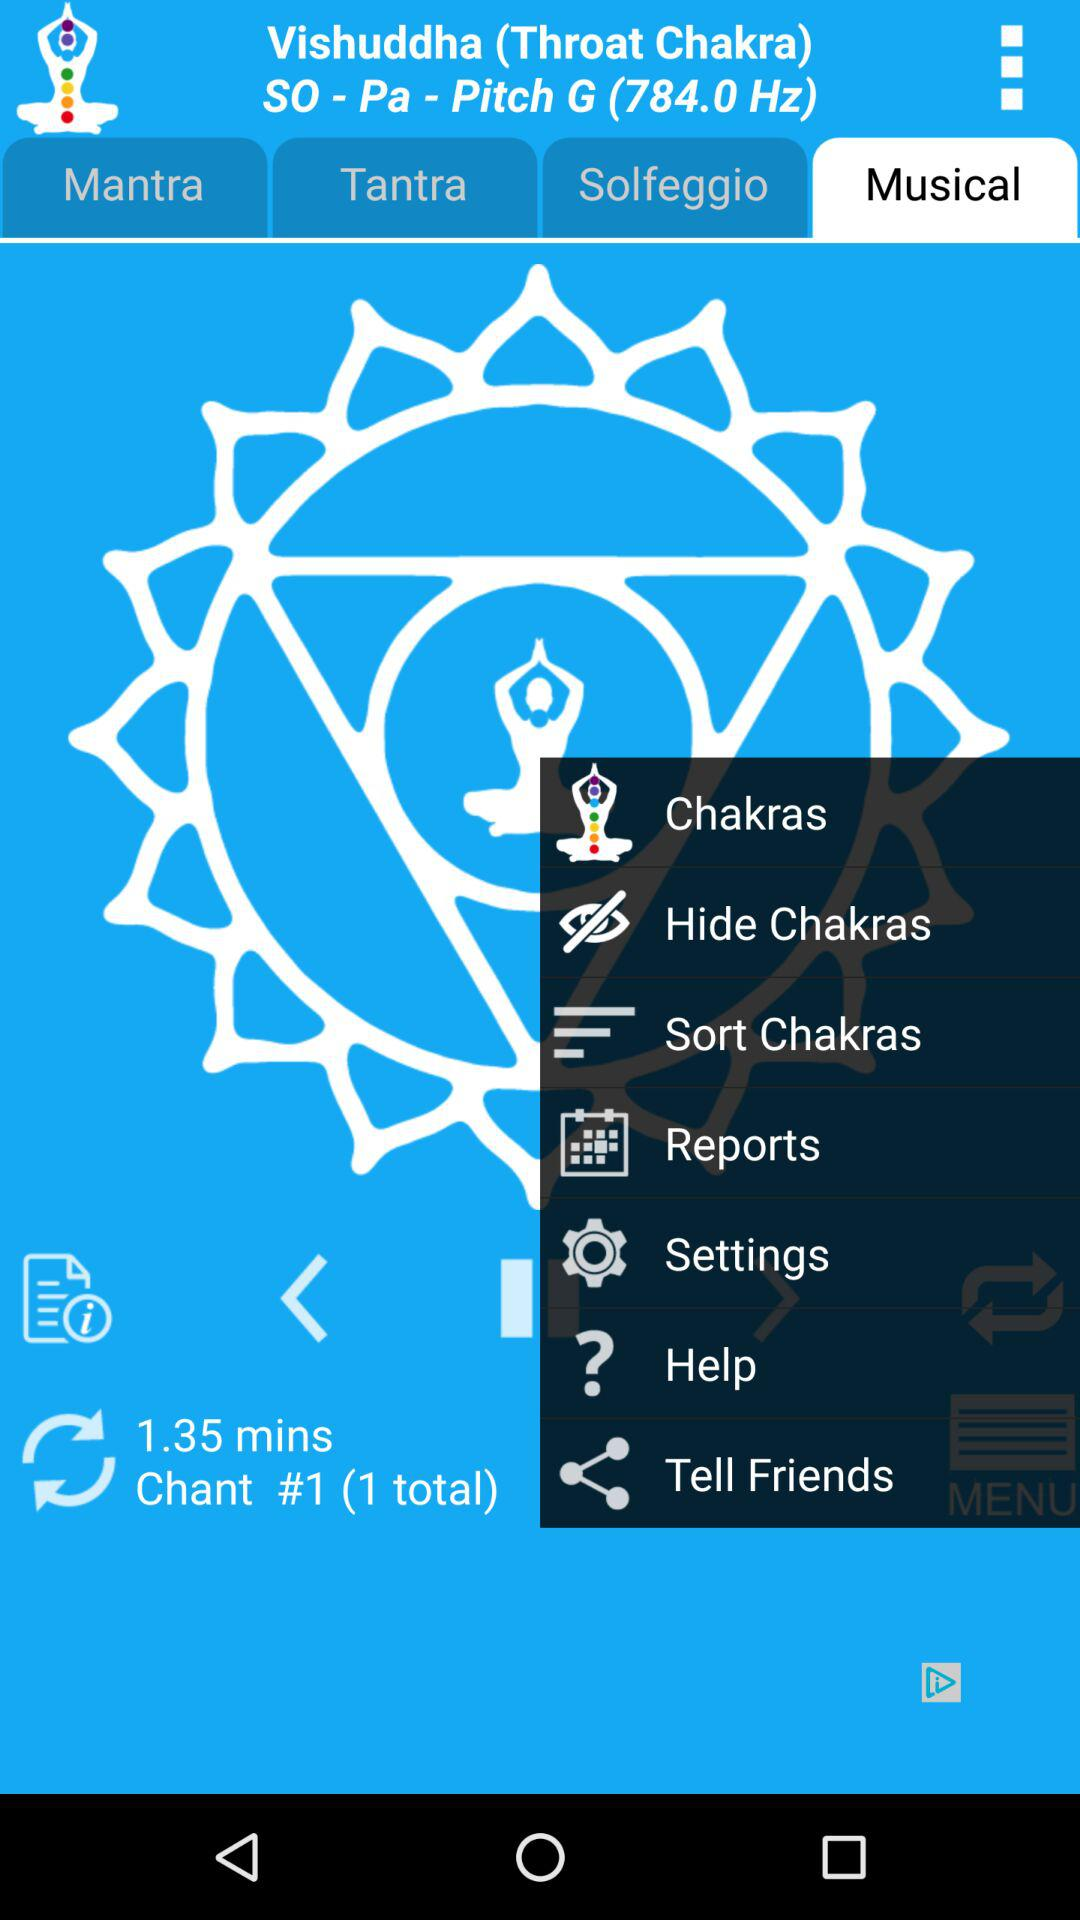Which tab am I on in "Vishuddha"? You are on the tab "Musical" in "Vishuddha". 